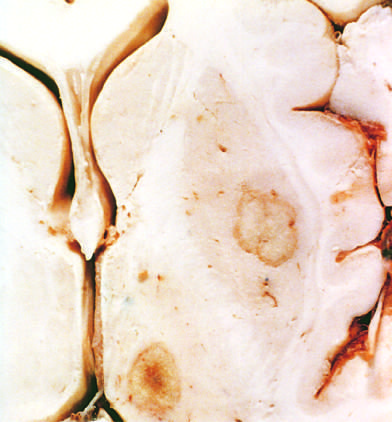re abscesses present in the putamen and thalamus?
Answer the question using a single word or phrase. Yes 